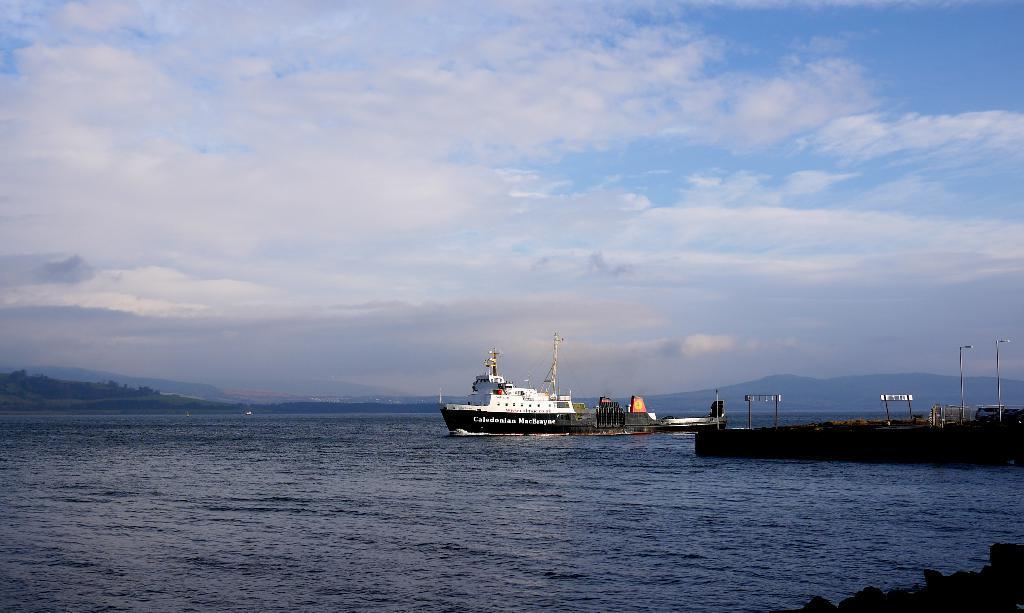Could you give a brief overview of what you see in this image? This is an outside view. Here I can see an ocean. In the middle of the image there is a ship on the water. On the right side there are few poles on the ground. At the top of the image, I can see the sky and clouds. 